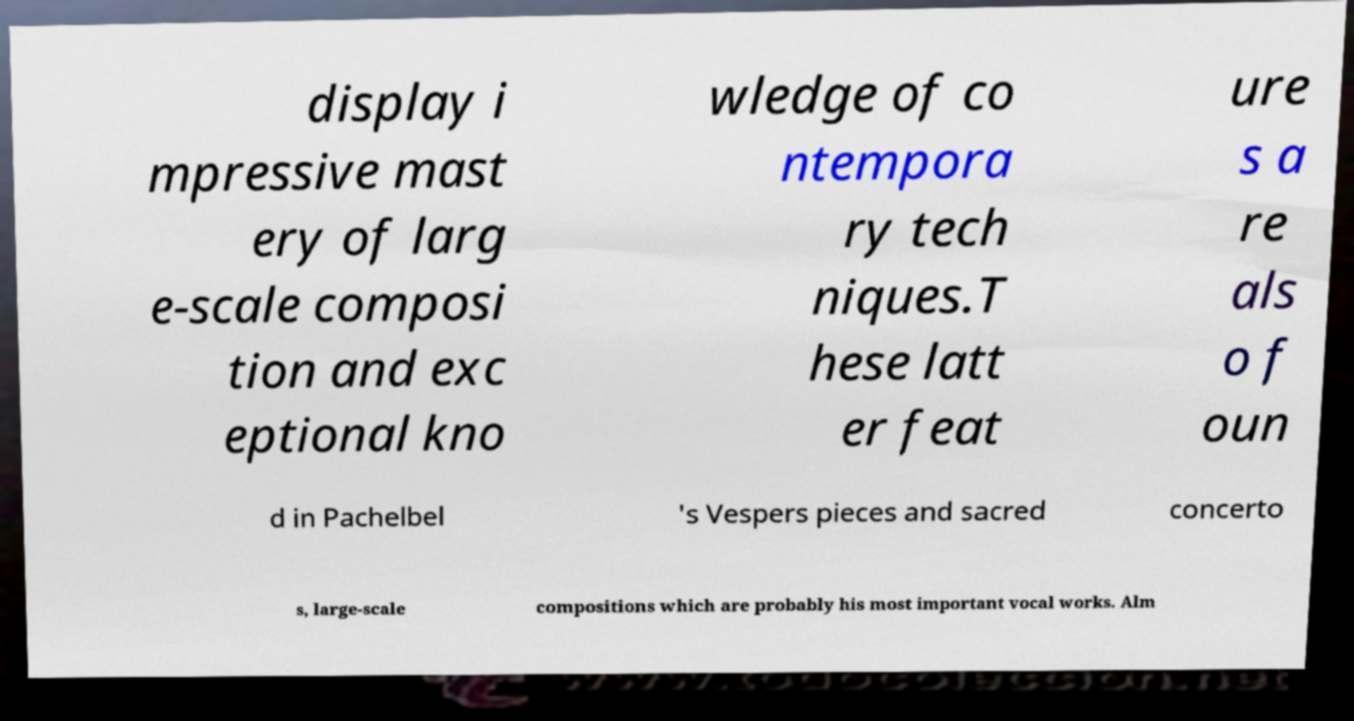What messages or text are displayed in this image? I need them in a readable, typed format. display i mpressive mast ery of larg e-scale composi tion and exc eptional kno wledge of co ntempora ry tech niques.T hese latt er feat ure s a re als o f oun d in Pachelbel 's Vespers pieces and sacred concerto s, large-scale compositions which are probably his most important vocal works. Alm 